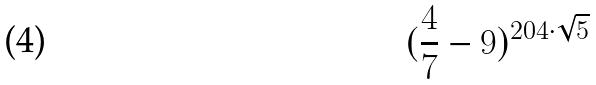Convert formula to latex. <formula><loc_0><loc_0><loc_500><loc_500>( \frac { 4 } { 7 } - 9 ) ^ { 2 0 4 \cdot \sqrt { 5 } }</formula> 